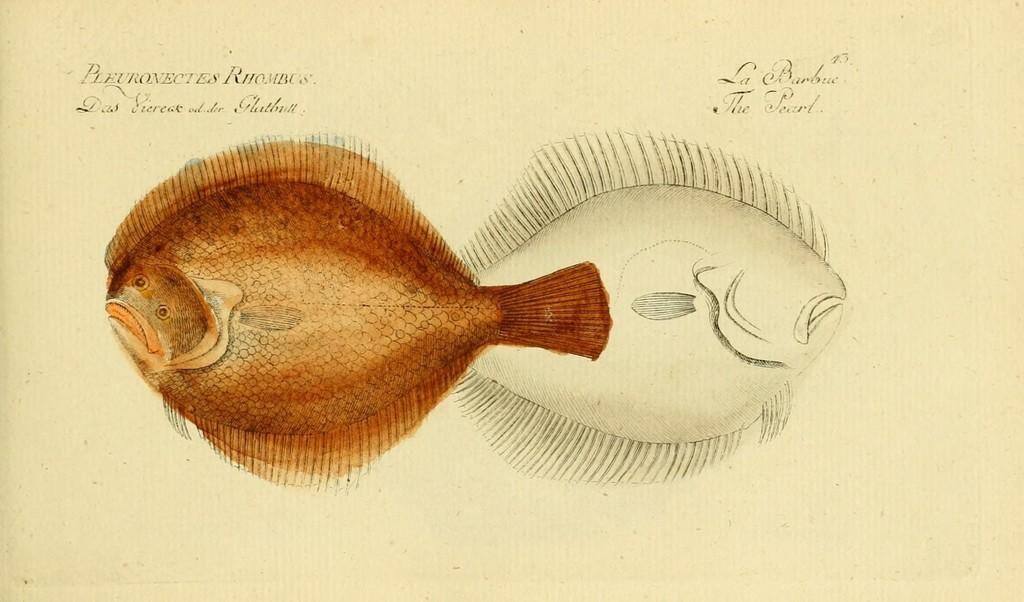What is featured on the poster in the image? The poster contains a design of a fish. Where is the quotation located on the poster? The quotation is in the top right corner of the poster. What type of nest can be seen in the image? There is no nest present in the image; it features a poster with a design of a fish and a quotation. 